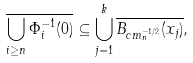<formula> <loc_0><loc_0><loc_500><loc_500>\overline { \bigcup _ { i \geq n } \Phi _ { i } ^ { - 1 } ( 0 ) } \subseteq \bigcup _ { j = 1 } ^ { k } \overline { B _ { c m _ { n } ^ { - 1 / 2 } } ( x _ { j } ) } ,</formula> 